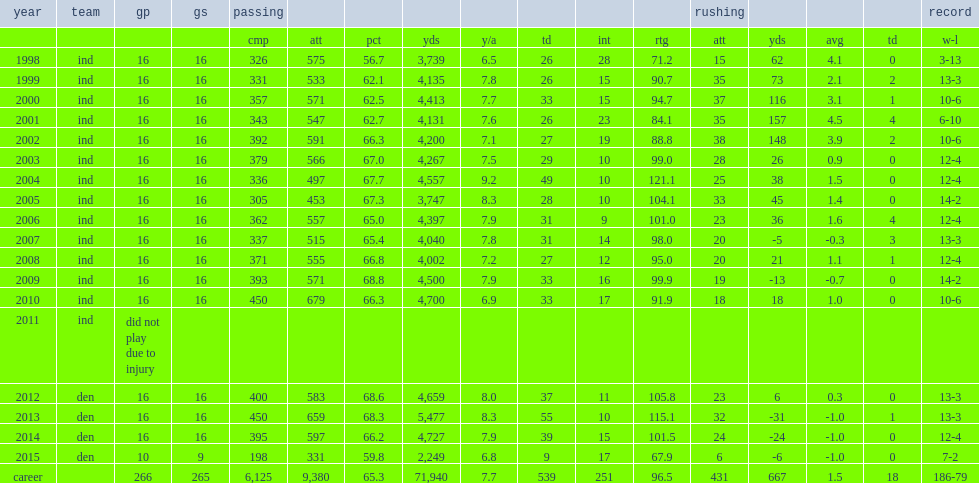How many passing yards did peyton manning get in 1999. 4135.0. 